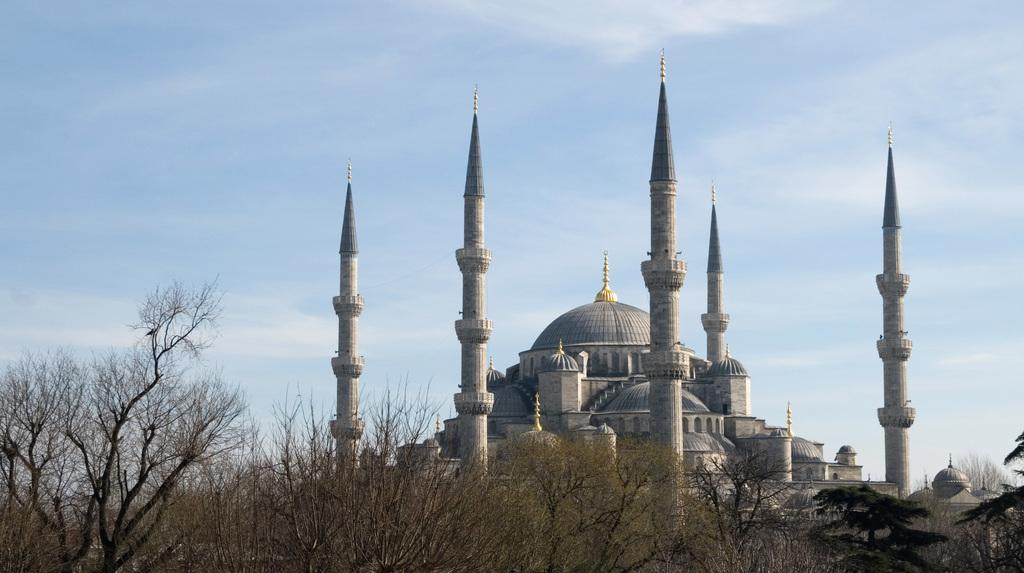What type of structure is depicted with a tower in the image? There is a building with a tower in the image. What type of monument can be seen in the image? There is a tomb in the image. What kind of vegetation is present at the bottom of the image? Dry trees are present at the bottom of the image. What is the color of the sky in the image? The sky is blue in color. Can you tell me where the seashore is located in the image? There is no seashore present in the image. What invention is being used to communicate with the spirits in the tomb? There is no mention of any invention or communication with spirits in the image. 